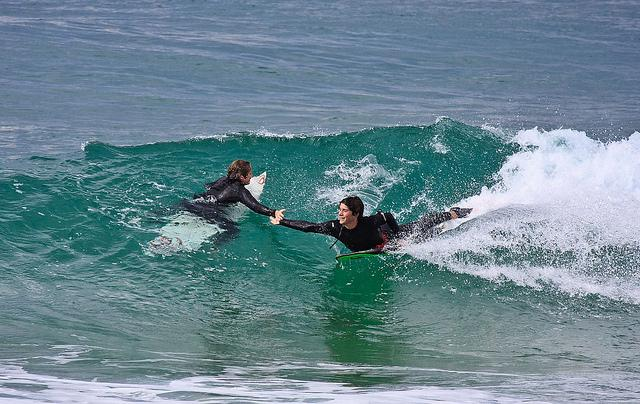What are the people holding?

Choices:
A) diapers
B) babies
C) bats
D) hands hands 